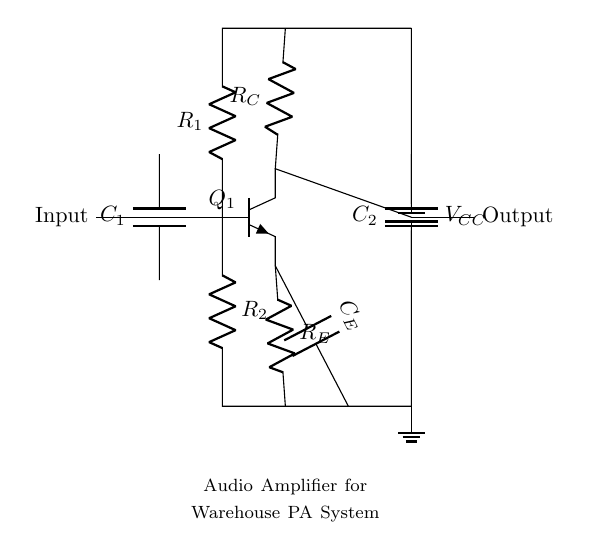What is the input component in this circuit? The input component is represented as a connection to the left of the circuit, which typically serves as the point where the audio signal enters the amplifier circuit.
Answer: Input What does the capacitor C1 do in this circuit? Capacitor C1 is used for coupling, allowing AC signals to pass while blocking DC components, effectively isolating the audio input from any DC voltage present.
Answer: Coupling How many resistors are present in the amplifier circuit? There are three resistors identified in the circuit: R1, R2, and RE. Each plays a specific role in biasing and stability of the transistor.
Answer: Three What type of transistor is used in this circuit? The transistor indicated in the circuit is an NPN transistor, which is a specific type of bipolar junction transistor that allows current to flow when an appropriate input signal is applied.
Answer: NPN What is the function of the output capacitor C2? Capacitor C2 is used as an output coupling capacitor, which allows the amplified AC signal to pass to the next stage or speaker while blocking any DC component that could affect performance.
Answer: Output coupling What is the voltage supply labeled in the circuit? The voltage supply is labeled as VCC, which is the positive voltage supply necessary for the operation of the transistor amplifier to provide the required gain for the audio signal.
Answer: VCC 